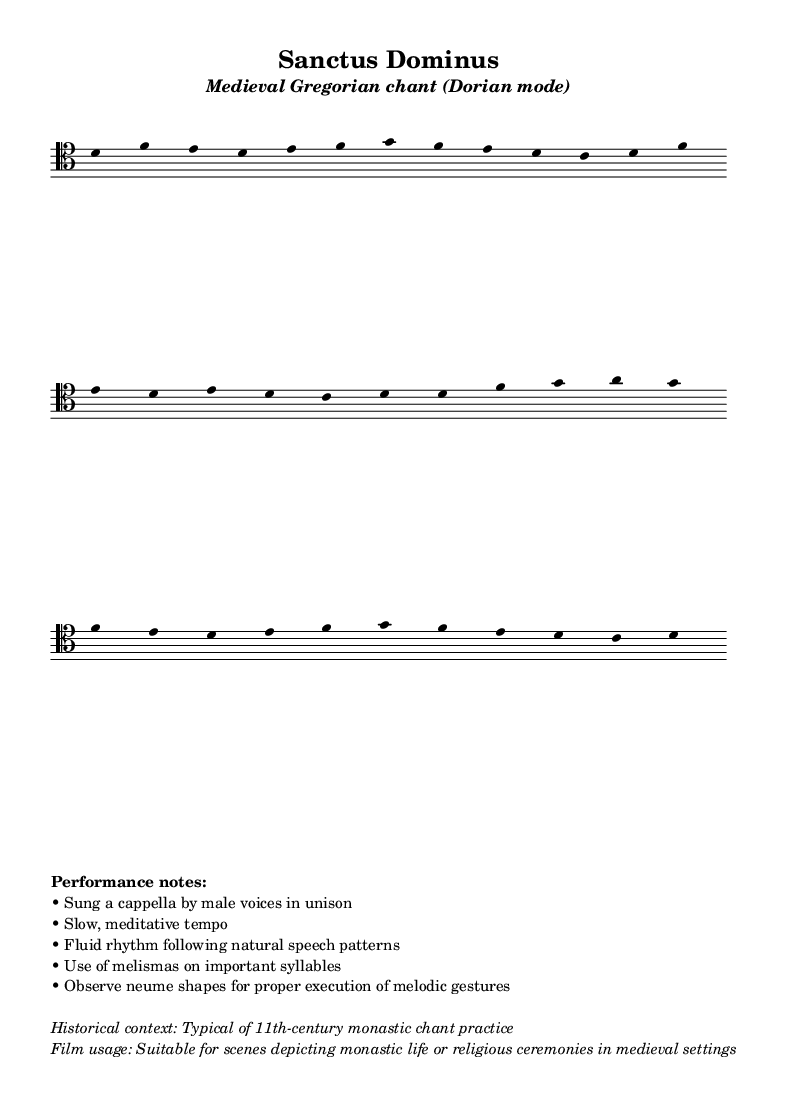What is the key signature of this music? The key signature is indicated at the beginning of the staff and is C major, which has no sharps or flats.
Answer: C major What is the tempo marking given in the MIDI section? The tempo marking is specified as "4 = 60," which indicates a quarter note beats per minute. Thus, the tempo is 60 beats per minute.
Answer: 60 How many lines are there in the lyrics? The lyrics section contains three lines, as indicated by the layout of the text in the score.
Answer: 3 What type of voices are indicated for performing this chant? The performance notes specify that the chant is sung a cappella by male voices in unison, indicating the type of vocal arrangement required.
Answer: Male voices What is the chant mode used in this piece? The subtitle of the header mentions "Dorian mode," which indicates the type of scale used in the composition.
Answer: Dorian mode How does the rhythm in this piece follow natural speech patterns? The performance notes state that the rhythm is fluid and follows natural speech patterns, suggesting there are no strict rhythmic divisions, making it more freeform.
Answer: Fluid rhythm 